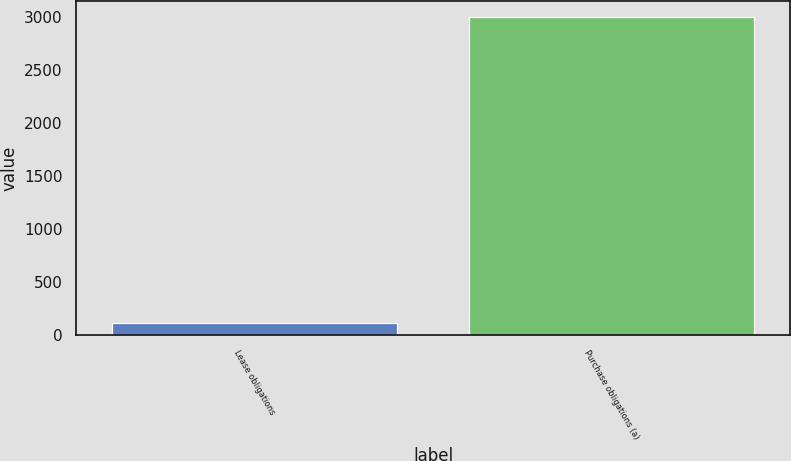<chart> <loc_0><loc_0><loc_500><loc_500><bar_chart><fcel>Lease obligations<fcel>Purchase obligations (a)<nl><fcel>118<fcel>3001<nl></chart> 